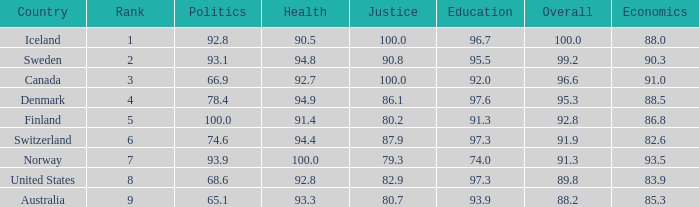What's the rank for iceland 1.0. 